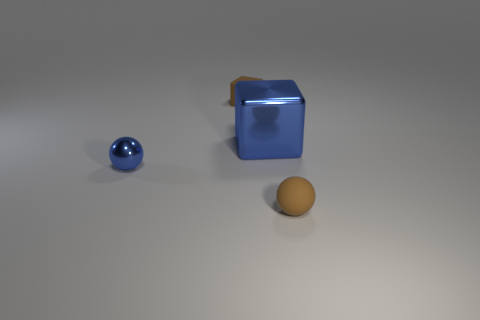Add 1 large metal objects. How many objects exist? 5 Add 2 brown rubber balls. How many brown rubber balls exist? 3 Subtract 1 blue balls. How many objects are left? 3 Subtract all tiny purple cubes. Subtract all small blue metallic objects. How many objects are left? 3 Add 1 matte cubes. How many matte cubes are left? 2 